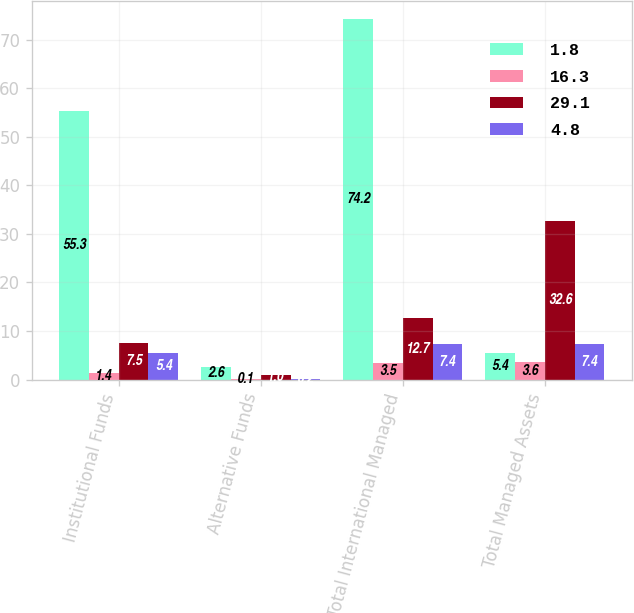Convert chart. <chart><loc_0><loc_0><loc_500><loc_500><stacked_bar_chart><ecel><fcel>Institutional Funds<fcel>Alternative Funds<fcel>Total International Managed<fcel>Total Managed Assets<nl><fcel>1.8<fcel>55.3<fcel>2.6<fcel>74.2<fcel>5.4<nl><fcel>16.3<fcel>1.4<fcel>0.1<fcel>3.5<fcel>3.6<nl><fcel>29.1<fcel>7.5<fcel>1<fcel>12.7<fcel>32.6<nl><fcel>4.8<fcel>5.4<fcel>0.2<fcel>7.4<fcel>7.4<nl></chart> 